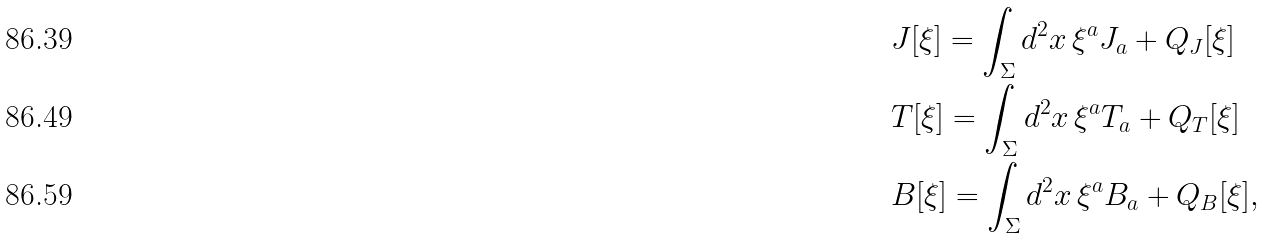<formula> <loc_0><loc_0><loc_500><loc_500>& J [ \xi ] = \int _ { \Sigma } d ^ { 2 } x \, \xi ^ { a } J _ { a } + Q _ { J } [ \xi ] \\ & T [ \xi ] = \int _ { \Sigma } d ^ { 2 } x \, \xi ^ { a } T _ { a } + Q _ { T } [ \xi ] \\ & B [ \xi ] = \int _ { \Sigma } d ^ { 2 } x \, \xi ^ { a } B _ { a } + Q _ { B } [ \xi ] ,</formula> 